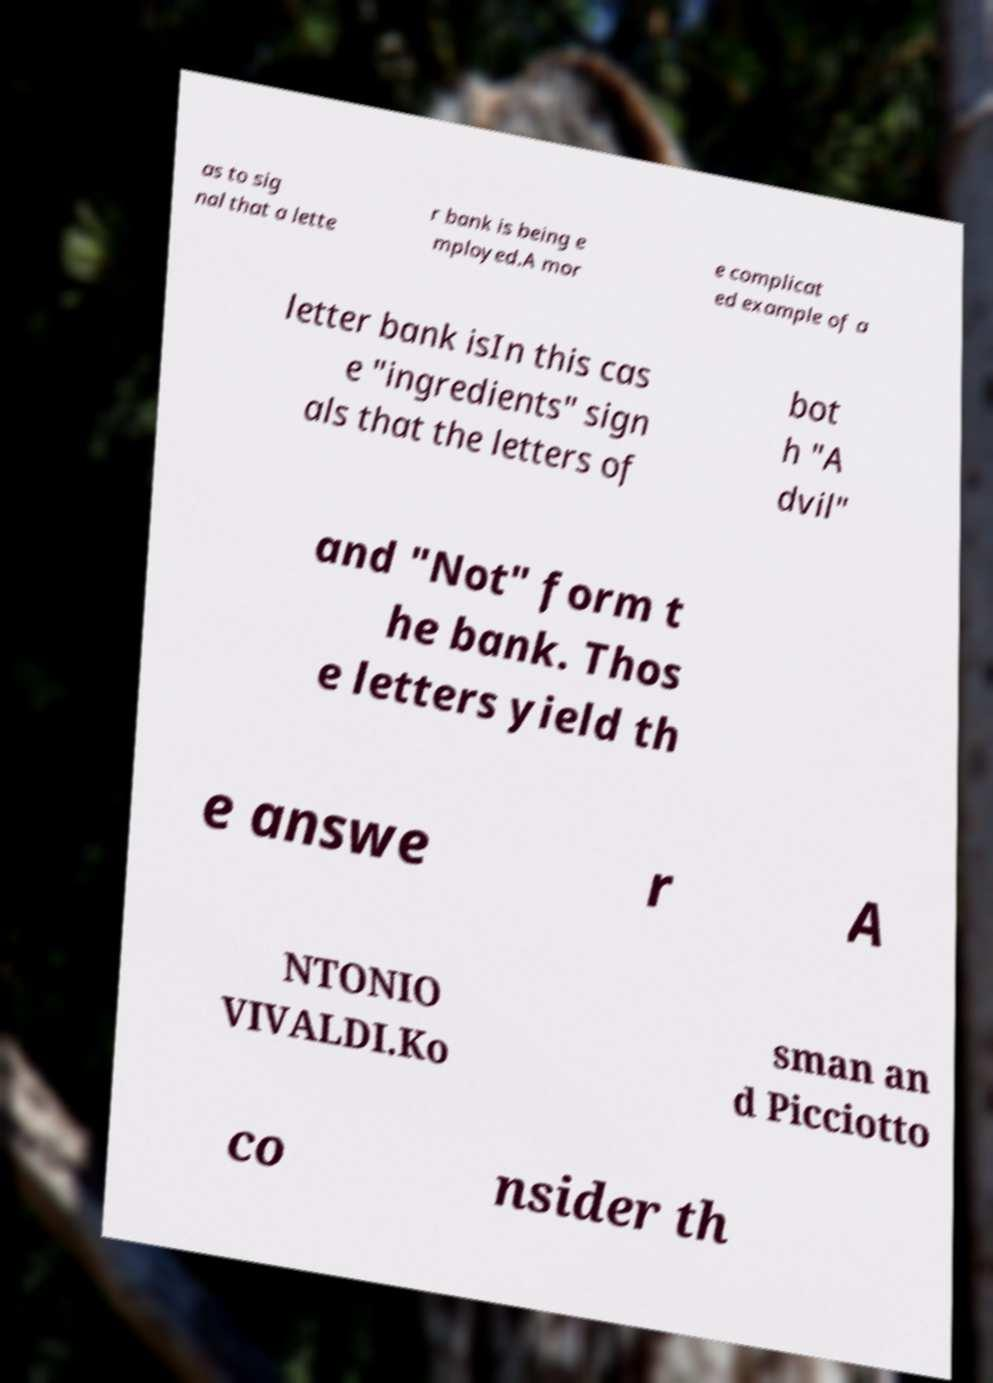What messages or text are displayed in this image? I need them in a readable, typed format. as to sig nal that a lette r bank is being e mployed.A mor e complicat ed example of a letter bank isIn this cas e "ingredients" sign als that the letters of bot h "A dvil" and "Not" form t he bank. Thos e letters yield th e answe r A NTONIO VIVALDI.Ko sman an d Picciotto co nsider th 